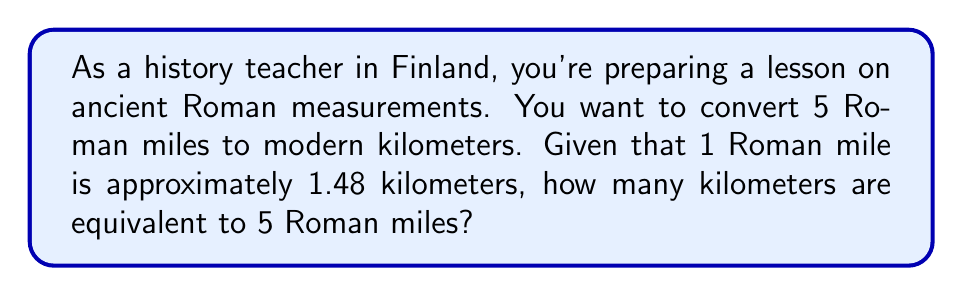Teach me how to tackle this problem. To solve this problem, we need to use the conversion factor between Roman miles and kilometers. Let's break it down step-by-step:

1. Given information:
   - 1 Roman mile ≈ 1.48 kilometers
   - We need to convert 5 Roman miles

2. Set up the conversion:
   $$ 5 \text{ Roman miles} \times \frac{1.48 \text{ km}}{1 \text{ Roman mile}} $$

3. Multiply the numbers:
   $$ 5 \times 1.48 = 7.4 $$

4. The units of Roman miles cancel out, leaving us with kilometers:
   $$ 7.4 \text{ km} $$

Therefore, 5 Roman miles is equivalent to 7.4 kilometers.

This conversion helps us understand the scale of distances in ancient Rome compared to modern measurements, which is valuable for teaching history and putting ancient events into perspective.
Answer: $7.4 \text{ km}$ 